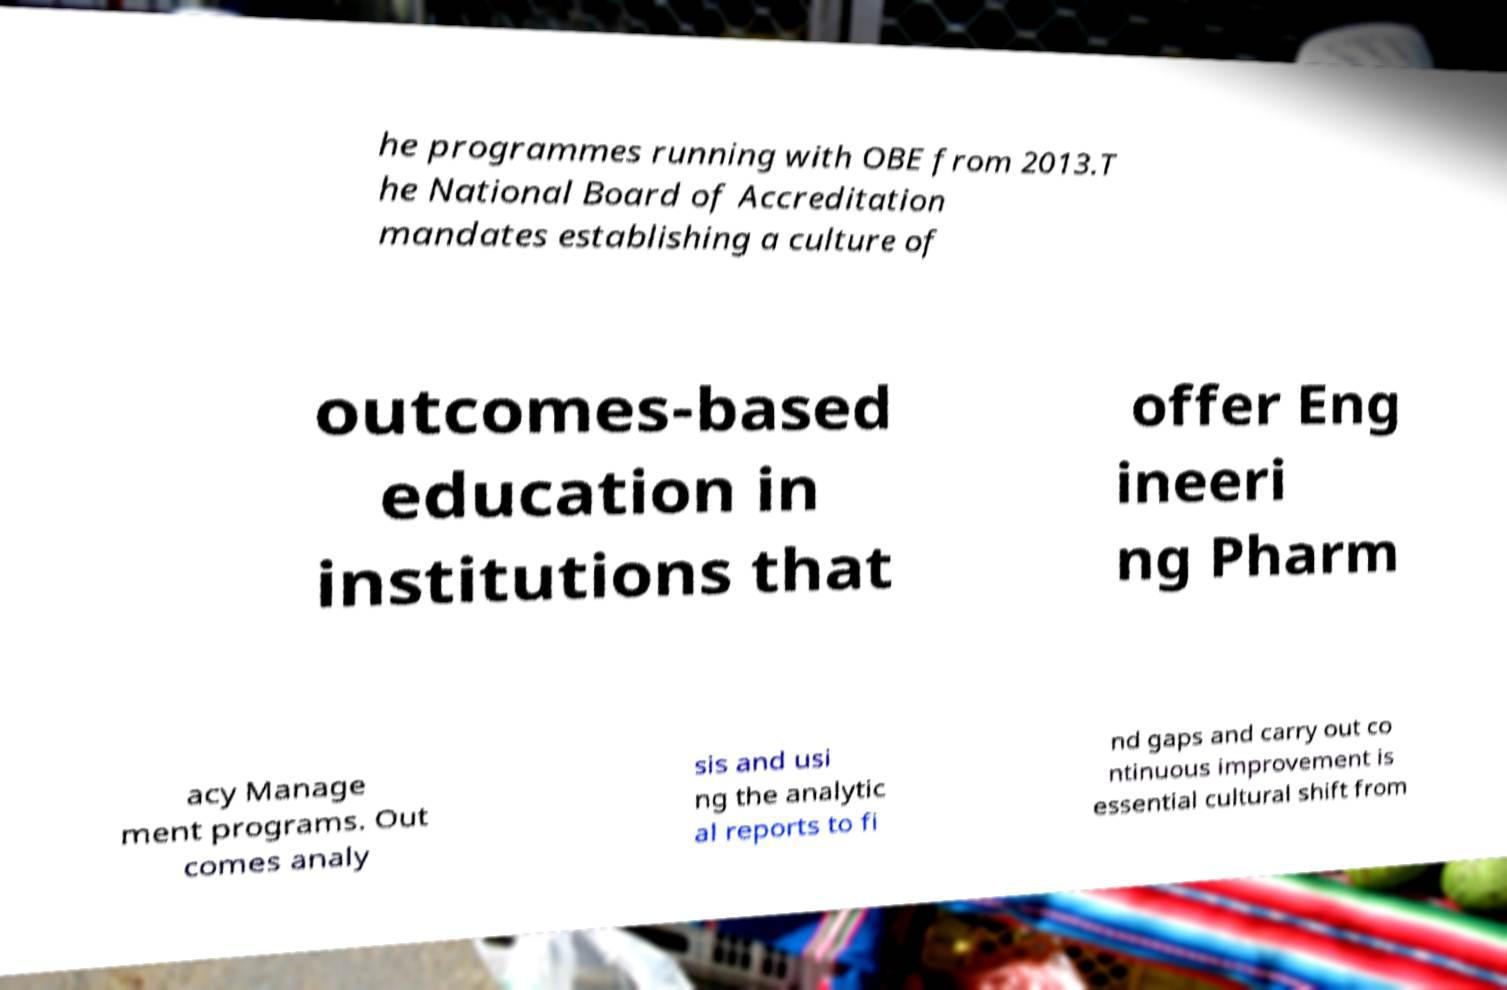Could you assist in decoding the text presented in this image and type it out clearly? he programmes running with OBE from 2013.T he National Board of Accreditation mandates establishing a culture of outcomes-based education in institutions that offer Eng ineeri ng Pharm acy Manage ment programs. Out comes analy sis and usi ng the analytic al reports to fi nd gaps and carry out co ntinuous improvement is essential cultural shift from 